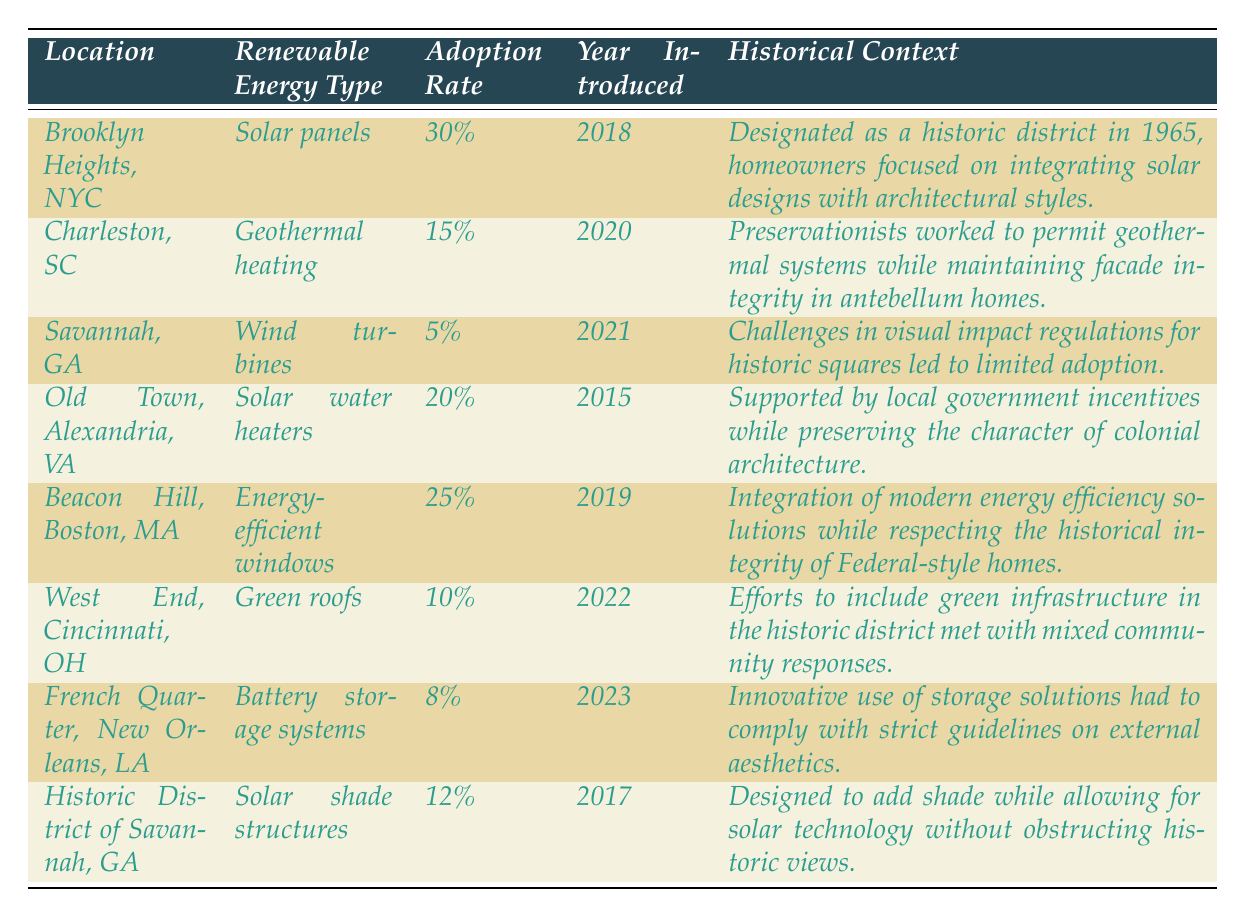What is the adoption rate for solar panels in Brooklyn Heights? The table lists the adoption rate for solar panels in Brooklyn Heights as 30%.
Answer: 30% Which renewable energy type has the highest adoption rate? By reviewing the adoption rates in the table, solar panels in Brooklyn Heights have the highest adoption rate at 30%.
Answer: Solar panels How many years ago was geothermal heating introduced in Charleston, SC? Geothermal heating was introduced in Charleston in 2020, and considering the current year is 2023, it was introduced 3 years ago.
Answer: 3 years ago Are wind turbines adopted more in Savannah, GA than battery storage systems in the French Quarter? The adoption rate for wind turbines in Savannah is 5%, while battery storage systems in the French Quarter have an adoption rate of 8%. Since 5% is less than 8%, wind turbines are not adopted more.
Answer: No What is the average adoption rate of renewable energy types in the highlighted cities (Brooklyn Heights, Charleston, Savannah, Old Town, Beacon Hill, West End, French Quarter, Historic District of Savannah)? The adoption rates are 30%, 15%, 5%, 20%, 25%, 10%, 8%, and 12%. Summing these gives 30 + 15 + 5 + 20 + 25 + 10 + 8 + 12 = 125. There are 8 locations; thus, the average is 125/8 = 15.625%.
Answer: 15.625% Which historic district had the lowest adoption rate of renewable energy? By comparing all adoption rates in the table, Savannah, GA had the lowest adoption rate with wind turbines at 5%.
Answer: Savannah, GA What are the years that saw the introduction of renewable energy types in Alexandria and Boston? The table specifies that solar water heaters were introduced in Alexandria in 2015 and energy-efficient windows in Boston in 2019.
Answer: 2015 for Alexandria, 2019 for Boston In which year was the highest number of renewable energy types introduced in this data? The years noted are 2015, 2017, 2018, 2019, 2020, 2021, 2022, and 2023. Each year had at most one type introduced. Hence, none had a higher number than others.
Answer: None Is the design of solar shade structures in Savannah specifically tailored to meet aesthetic guidelines? The historical context for solar shade structures in Savannah mentions the designs were made to use solar technology while allowing for views of historic architecture, indicating compliance with aesthetic guidelines.
Answer: Yes How much higher is the adoption rate of energy-efficient windows in Beacon Hill than green roofs in Cincinnati? Energy-efficient windows have a 25% adoption rate, while green roofs have a 10% adoption rate. The difference is 25% - 10% = 15%.
Answer: 15% higher Which renewable energy type had the latest introduction year? The table indicates that battery storage systems were introduced in 2023, which is the latest year compared to others.
Answer: Battery storage systems 